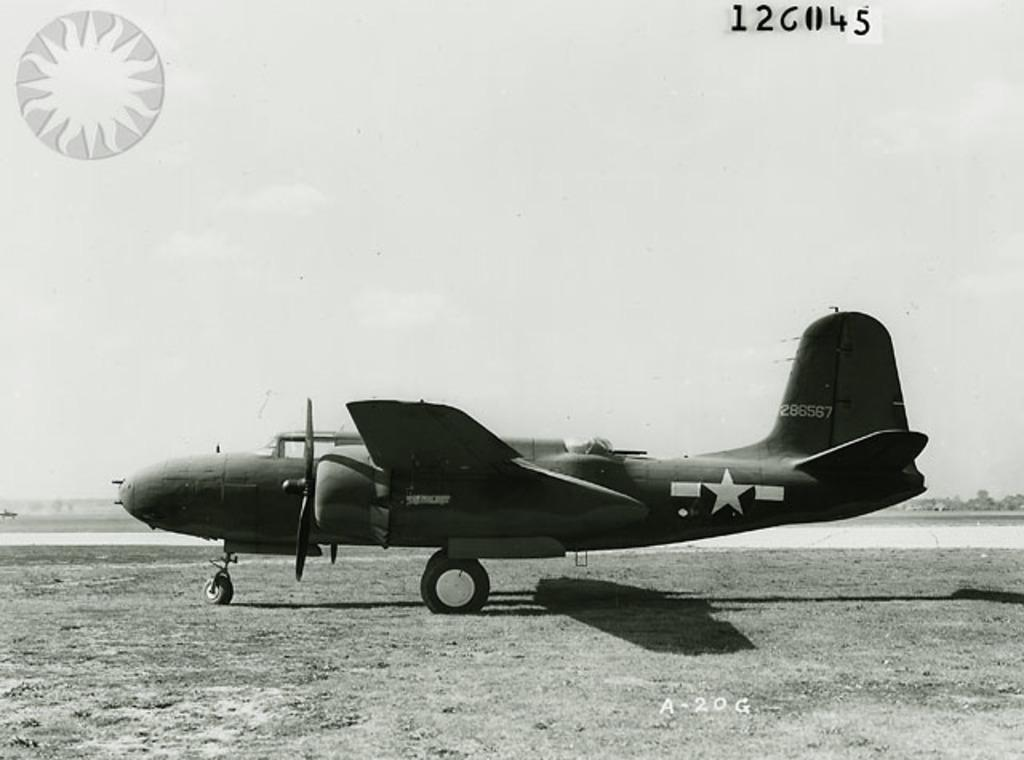<image>
Present a compact description of the photo's key features. Old aircraft with the call sign 286567 sits alone in a field. 